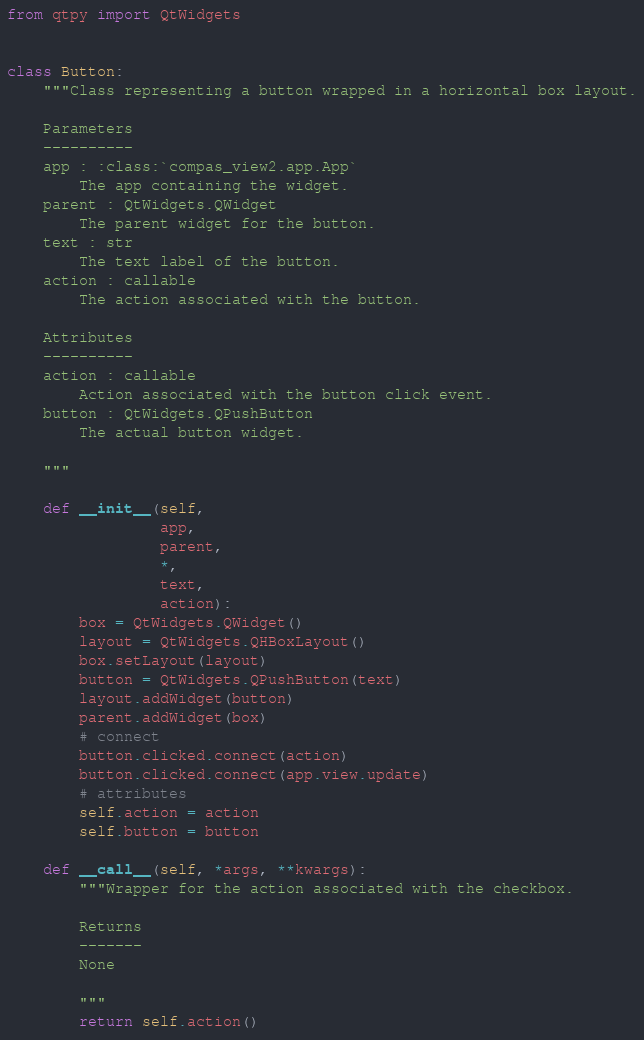Convert code to text. <code><loc_0><loc_0><loc_500><loc_500><_Python_>from qtpy import QtWidgets


class Button:
    """Class representing a button wrapped in a horizontal box layout.

    Parameters
    ----------
    app : :class:`compas_view2.app.App`
        The app containing the widget.
    parent : QtWidgets.QWidget
        The parent widget for the button.
    text : str
        The text label of the button.
    action : callable
        The action associated with the button.

    Attributes
    ----------
    action : callable
        Action associated with the button click event.
    button : QtWidgets.QPushButton
        The actual button widget.

    """

    def __init__(self,
                 app,
                 parent,
                 *,
                 text,
                 action):
        box = QtWidgets.QWidget()
        layout = QtWidgets.QHBoxLayout()
        box.setLayout(layout)
        button = QtWidgets.QPushButton(text)
        layout.addWidget(button)
        parent.addWidget(box)
        # connect
        button.clicked.connect(action)
        button.clicked.connect(app.view.update)
        # attributes
        self.action = action
        self.button = button

    def __call__(self, *args, **kwargs):
        """Wrapper for the action associated with the checkbox.

        Returns
        -------
        None

        """
        return self.action()
</code> 